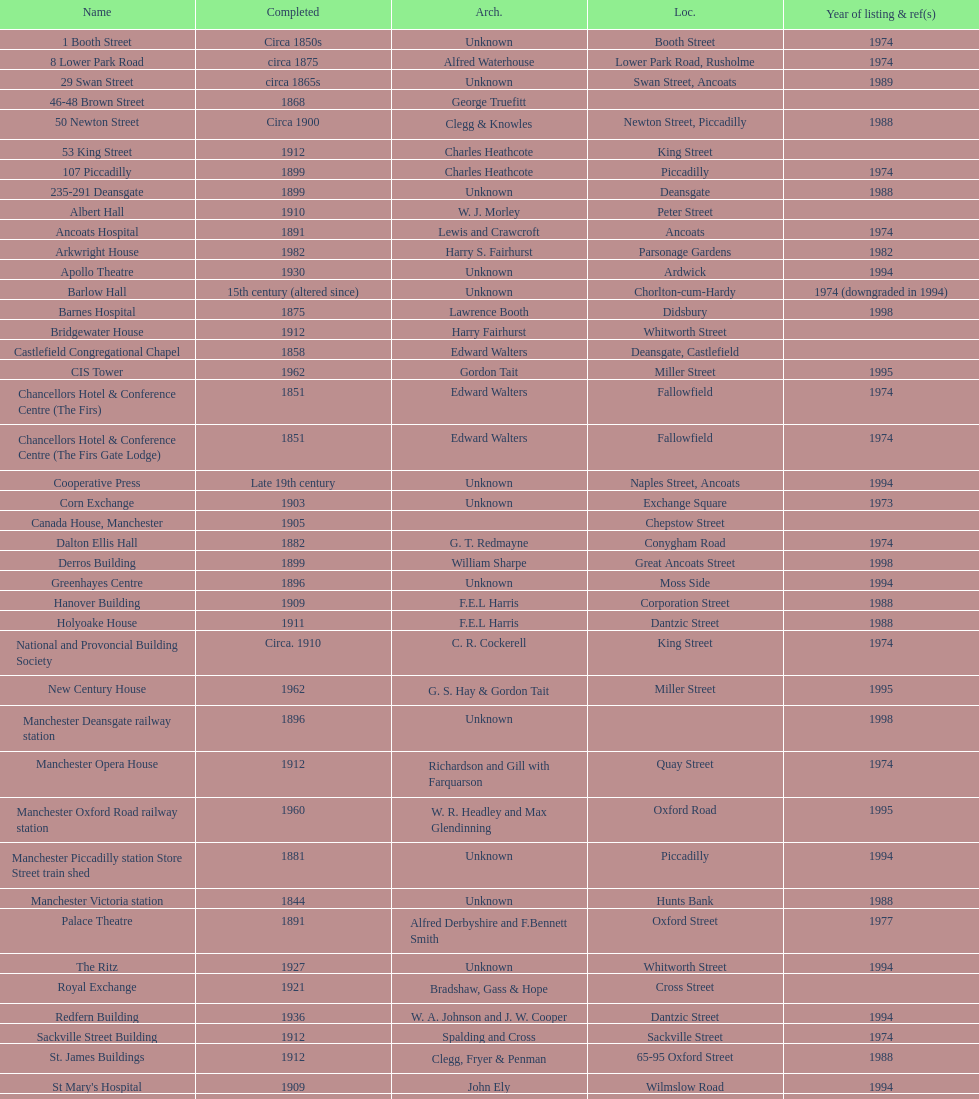What is the difference, in years, between the completion dates of 53 king street and castlefield congregational chapel? 54 years. 